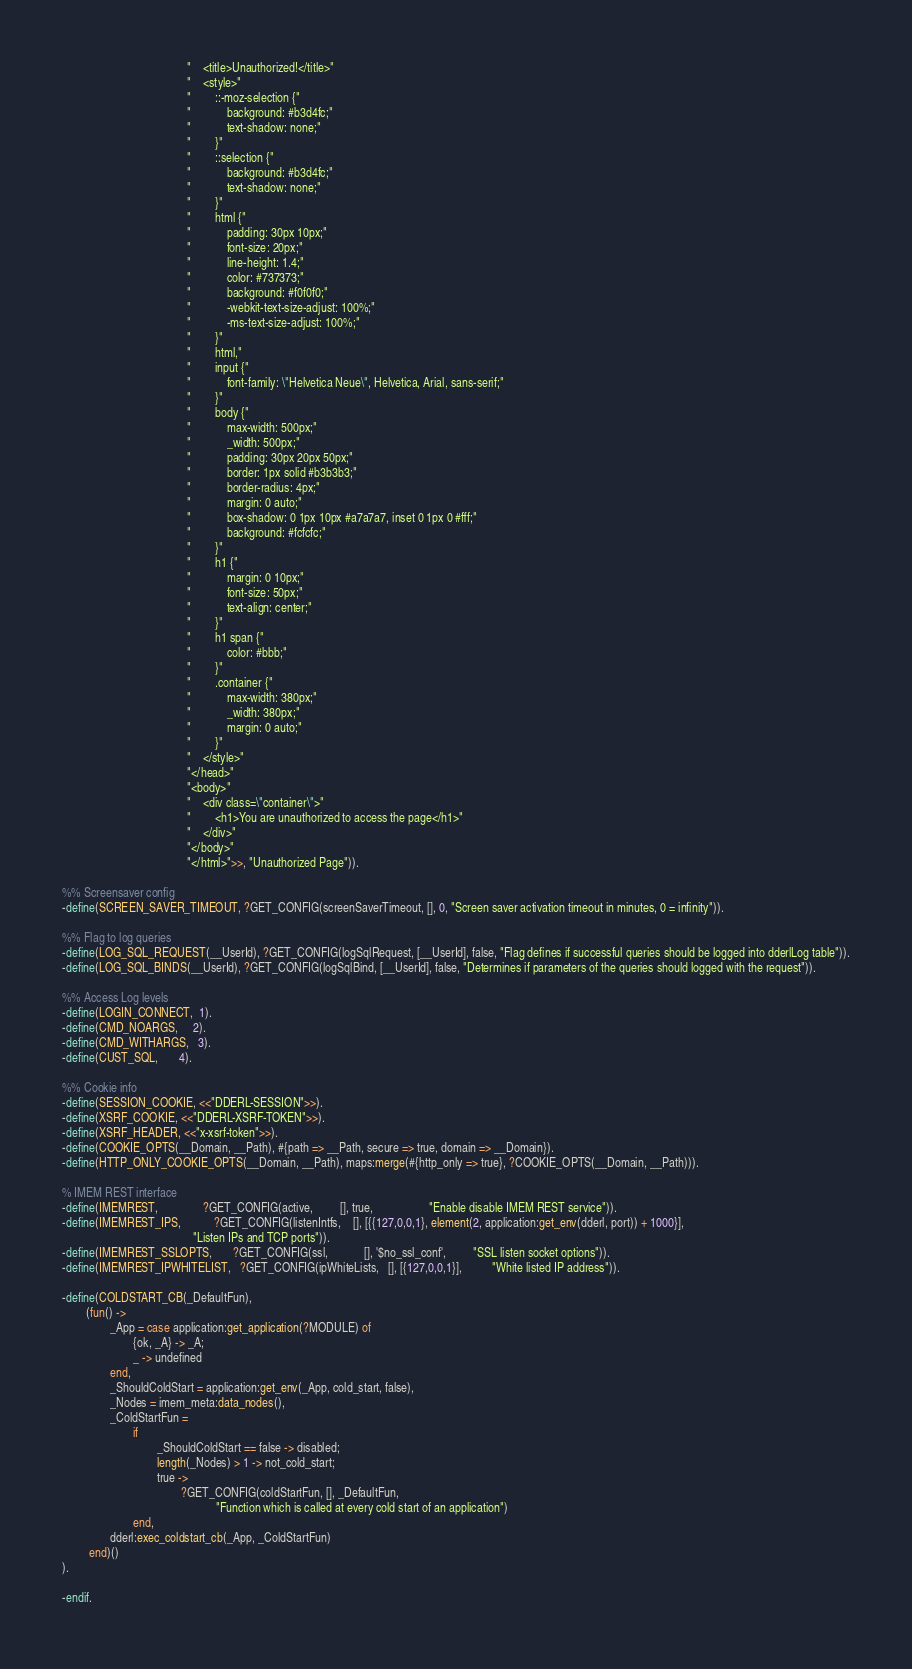<code> <loc_0><loc_0><loc_500><loc_500><_Erlang_>                                          "    <title>Unauthorized!</title>"
                                          "    <style>"
                                          "        ::-moz-selection {"
                                          "            background: #b3d4fc;"
                                          "            text-shadow: none;"
                                          "        }"
                                          "        ::selection {"
                                          "            background: #b3d4fc;"
                                          "            text-shadow: none;"
                                          "        }"
                                          "        html {"
                                          "            padding: 30px 10px;"
                                          "            font-size: 20px;"
                                          "            line-height: 1.4;"
                                          "            color: #737373;"
                                          "            background: #f0f0f0;"
                                          "            -webkit-text-size-adjust: 100%;"
                                          "            -ms-text-size-adjust: 100%;"
                                          "        }"
                                          "        html,"
                                          "        input {"
                                          "            font-family: \"Helvetica Neue\", Helvetica, Arial, sans-serif;"
                                          "        }"
                                          "        body {"
                                          "            max-width: 500px;"
                                          "            _width: 500px;"
                                          "            padding: 30px 20px 50px;"
                                          "            border: 1px solid #b3b3b3;"
                                          "            border-radius: 4px;"
                                          "            margin: 0 auto;"
                                          "            box-shadow: 0 1px 10px #a7a7a7, inset 0 1px 0 #fff;"
                                          "            background: #fcfcfc;"
                                          "        }"
                                          "        h1 {"
                                          "            margin: 0 10px;"
                                          "            font-size: 50px;"
                                          "            text-align: center;"
                                          "        }"
                                          "        h1 span {"
                                          "            color: #bbb;"
                                          "        }"
                                          "        .container {"
                                          "            max-width: 380px;"
                                          "            _width: 380px;"
                                          "            margin: 0 auto;"
                                          "        }"
                                          "    </style>"
                                          "</head>"
                                          "<body>"
                                          "    <div class=\"container\">"
                                          "        <h1>You are unauthorized to access the page</h1>"
                                          "    </div>"
                                          "</body>"
                                          "</html>">>, "Unauthorized Page")).

%% Screensaver config
-define(SCREEN_SAVER_TIMEOUT, ?GET_CONFIG(screenSaverTimeout, [], 0, "Screen saver activation timeout in minutes, 0 = infinity")).

%% Flag to log queries
-define(LOG_SQL_REQUEST(__UserId), ?GET_CONFIG(logSqlRequest, [__UserId], false, "Flag defines if successful queries should be logged into dderlLog table")).
-define(LOG_SQL_BINDS(__UserId), ?GET_CONFIG(logSqlBind, [__UserId], false, "Determines if parameters of the queries should logged with the request")).

%% Access Log levels
-define(LOGIN_CONNECT,  1).
-define(CMD_NOARGS,     2).
-define(CMD_WITHARGS,   3).
-define(CUST_SQL,       4).

%% Cookie info
-define(SESSION_COOKIE, <<"DDERL-SESSION">>).
-define(XSRF_COOKIE, <<"DDERL-XSRF-TOKEN">>).
-define(XSRF_HEADER, <<"x-xsrf-token">>).
-define(COOKIE_OPTS(__Domain, __Path), #{path => __Path, secure => true, domain => __Domain}).
-define(HTTP_ONLY_COOKIE_OPTS(__Domain, __Path), maps:merge(#{http_only => true}, ?COOKIE_OPTS(__Domain, __Path))).

% IMEM REST interface
-define(IMEMREST,               ?GET_CONFIG(active,         [], true,                   "Enable disable IMEM REST service")).
-define(IMEMREST_IPS,           ?GET_CONFIG(listenIntfs,    [], [{{127,0,0,1}, element(2, application:get_env(dderl, port)) + 1000}],
                                            "Listen IPs and TCP ports")).
-define(IMEMREST_SSLOPTS,       ?GET_CONFIG(ssl,            [], '$no_ssl_conf',         "SSL listen socket options")).
-define(IMEMREST_IPWHITELIST,   ?GET_CONFIG(ipWhiteLists,   [], [{127,0,0,1}],          "White listed IP address")).

-define(COLDSTART_CB(_DefaultFun),
        (fun() ->
                _App = case application:get_application(?MODULE) of
                        {ok, _A} -> _A;
                        _ -> undefined
                end,
                _ShouldColdStart = application:get_env(_App, cold_start, false),
                _Nodes = imem_meta:data_nodes(),
                _ColdStartFun =
                        if
                                _ShouldColdStart == false -> disabled;
                                length(_Nodes) > 1 -> not_cold_start;
                                true ->
                                        ?GET_CONFIG(coldStartFun, [], _DefaultFun,
                                                    "Function which is called at every cold start of an application")
                        end,
                dderl:exec_coldstart_cb(_App, _ColdStartFun)
         end)()
).

-endif.
</code> 